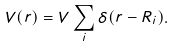<formula> <loc_0><loc_0><loc_500><loc_500>V ( r ) = V \sum _ { i } \delta ( r - R _ { i } ) .</formula> 